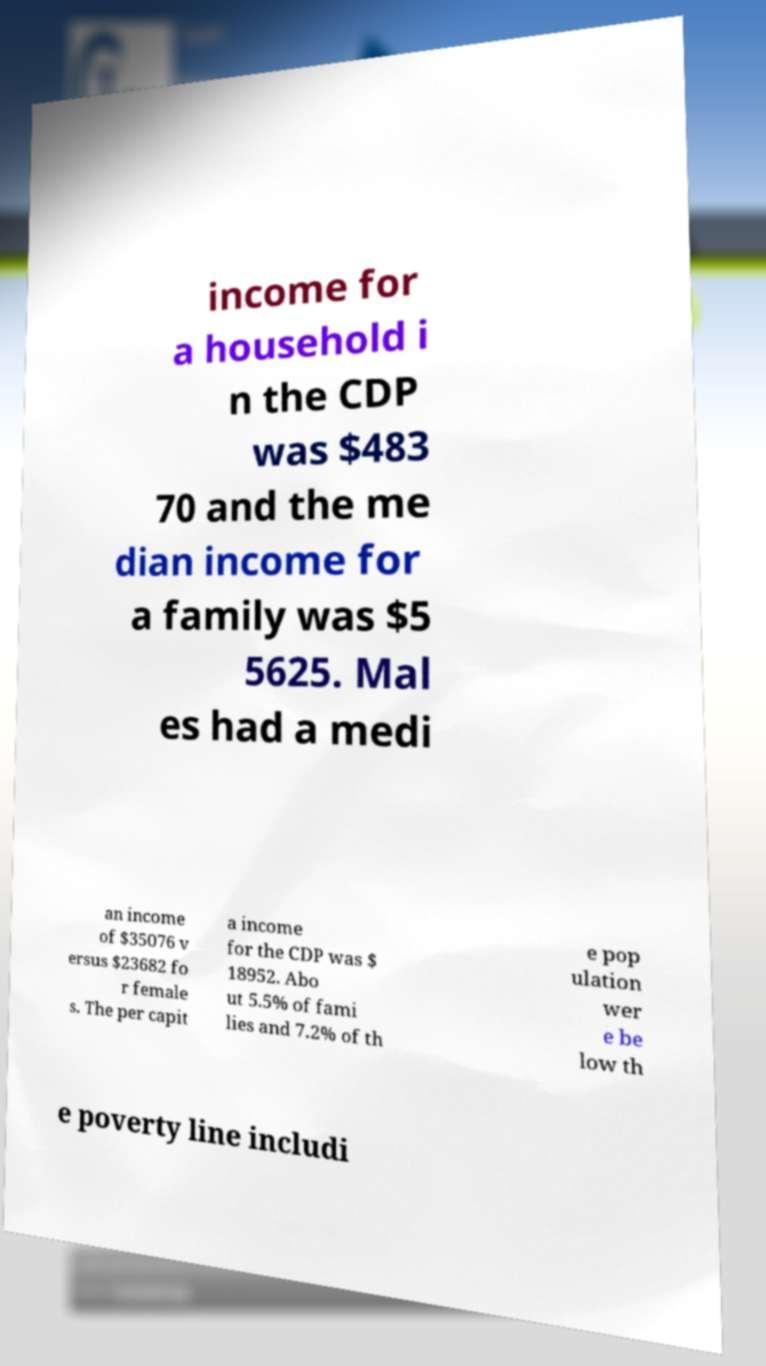Can you read and provide the text displayed in the image?This photo seems to have some interesting text. Can you extract and type it out for me? income for a household i n the CDP was $483 70 and the me dian income for a family was $5 5625. Mal es had a medi an income of $35076 v ersus $23682 fo r female s. The per capit a income for the CDP was $ 18952. Abo ut 5.5% of fami lies and 7.2% of th e pop ulation wer e be low th e poverty line includi 